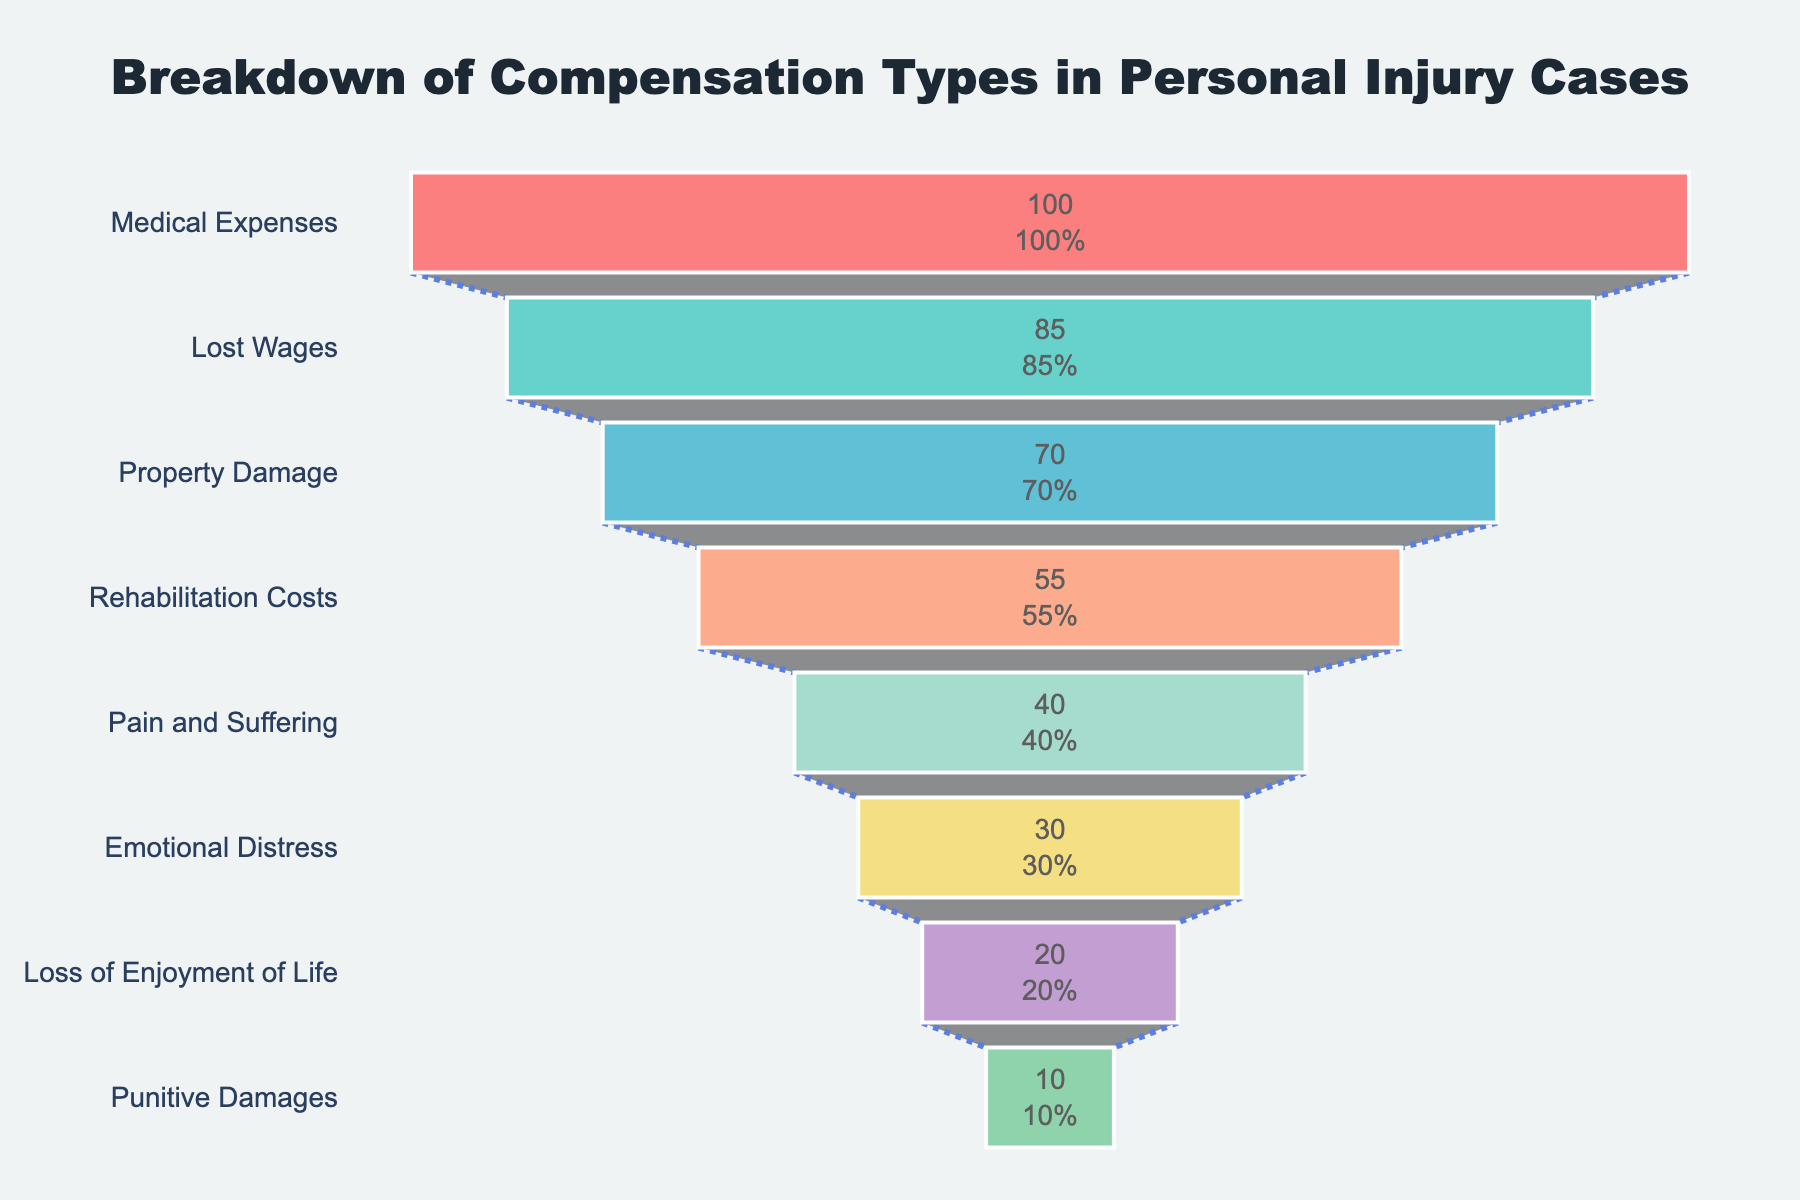What is the main title of the figure? The title is prominently displayed at the top of the figure. It provides an overview or context for what the chart is showing.
Answer: Breakdown of Compensation Types in Personal Injury Cases What percentage is represented by Medical Expenses? The category values are listed along the y-axis, and the corresponding percentages are displayed within the funnel sections. Medical Expenses is the top category, and its percentage is 100%.
Answer: 100% Which compensation type has the smallest percentage? The funnel chart sorts categories by decreasing percentage values from top to bottom, indicating that the smallest percentage is at the bottom.
Answer: Punitive Damages What is the percentage difference between Lost Wages and Rehabilitation Costs? Lost Wages have a percentage of 85%, and Rehabilitation Costs have a percentage of 55%. Subtracting 55% from 85% gives the difference.
Answer: 30% List all compensation types that have a percentage lower than 50%. The funnel sections corresponding to each percentage are noted, and those lower than 50% are chosen: Pain and Suffering, Emotional Distress, Loss of Enjoyment of Life, and Punitive Damages.
Answer: Pain and Suffering, Emotional Distress, Loss of Enjoyment of Life, Punitive Damages What are the second and third largest compensation types in terms of percentage? The categories sorted by descending percentage values show that the second largest is Lost Wages (85%) and the third largest is Property Damage (70%).
Answer: Lost Wages, Property Damage How does the percentage for Emotional Distress compare to that for Pain and Suffering? From the chart, Pain and Suffering has a percentage of 40%, while Emotional Distress has 30%. Comparatively speaking, Emotional Distress is 10% lower than Pain and Suffering.
Answer: Emotional Distress is 10% lower What is the combined percentage of Rehabilitation Costs and Emotional Distress? The percentage values for these categories are Rehabilitation Costs (55%) and Emotional Distress (30%). Adding them together gives the combined percentage.
Answer: 85% Which compensation type is just above Emotional Distress in terms of percentage? The chart arranges categories vertically by percentage values; thus, the category just above Emotional Distress (30%) is Pain and Suffering (40%).
Answer: Pain and Suffering How many compensation types are included in the funnel chart? Counting the number of distinct sections or categories along the y-axis of the funnel chart gives the total number.
Answer: 8 